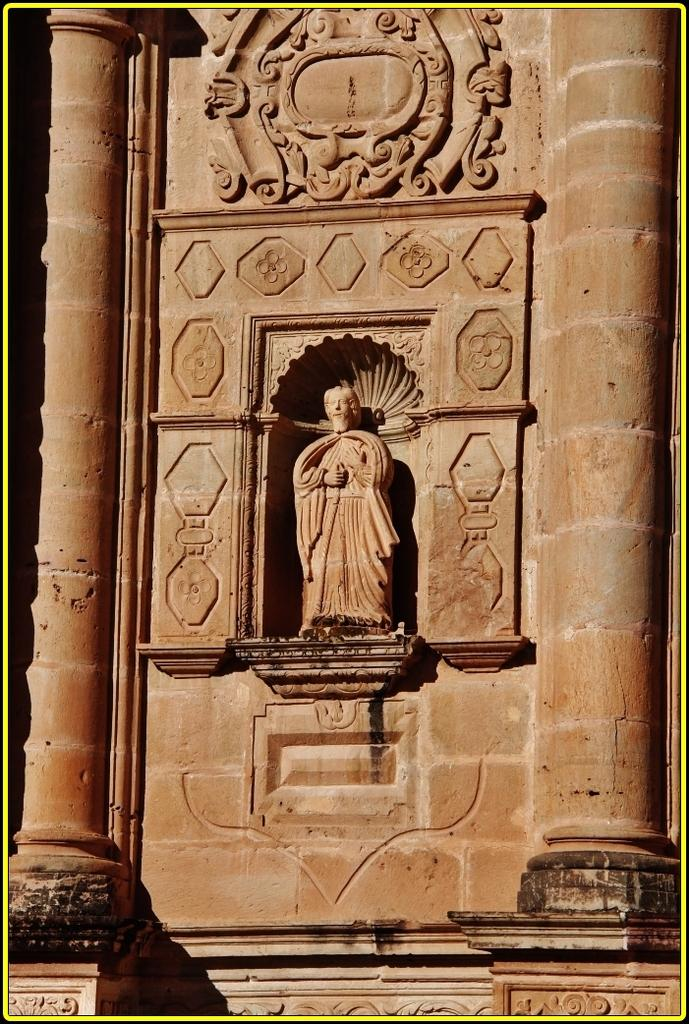What is present on the wall in the image? There are carved sculptures on the wall in the image. Can you describe the sculptures on the wall? The sculptures are carved into the wall. What type of flowers can be seen growing on the wall in the image? There are no flowers present on the wall in the image; it features carved sculptures. 